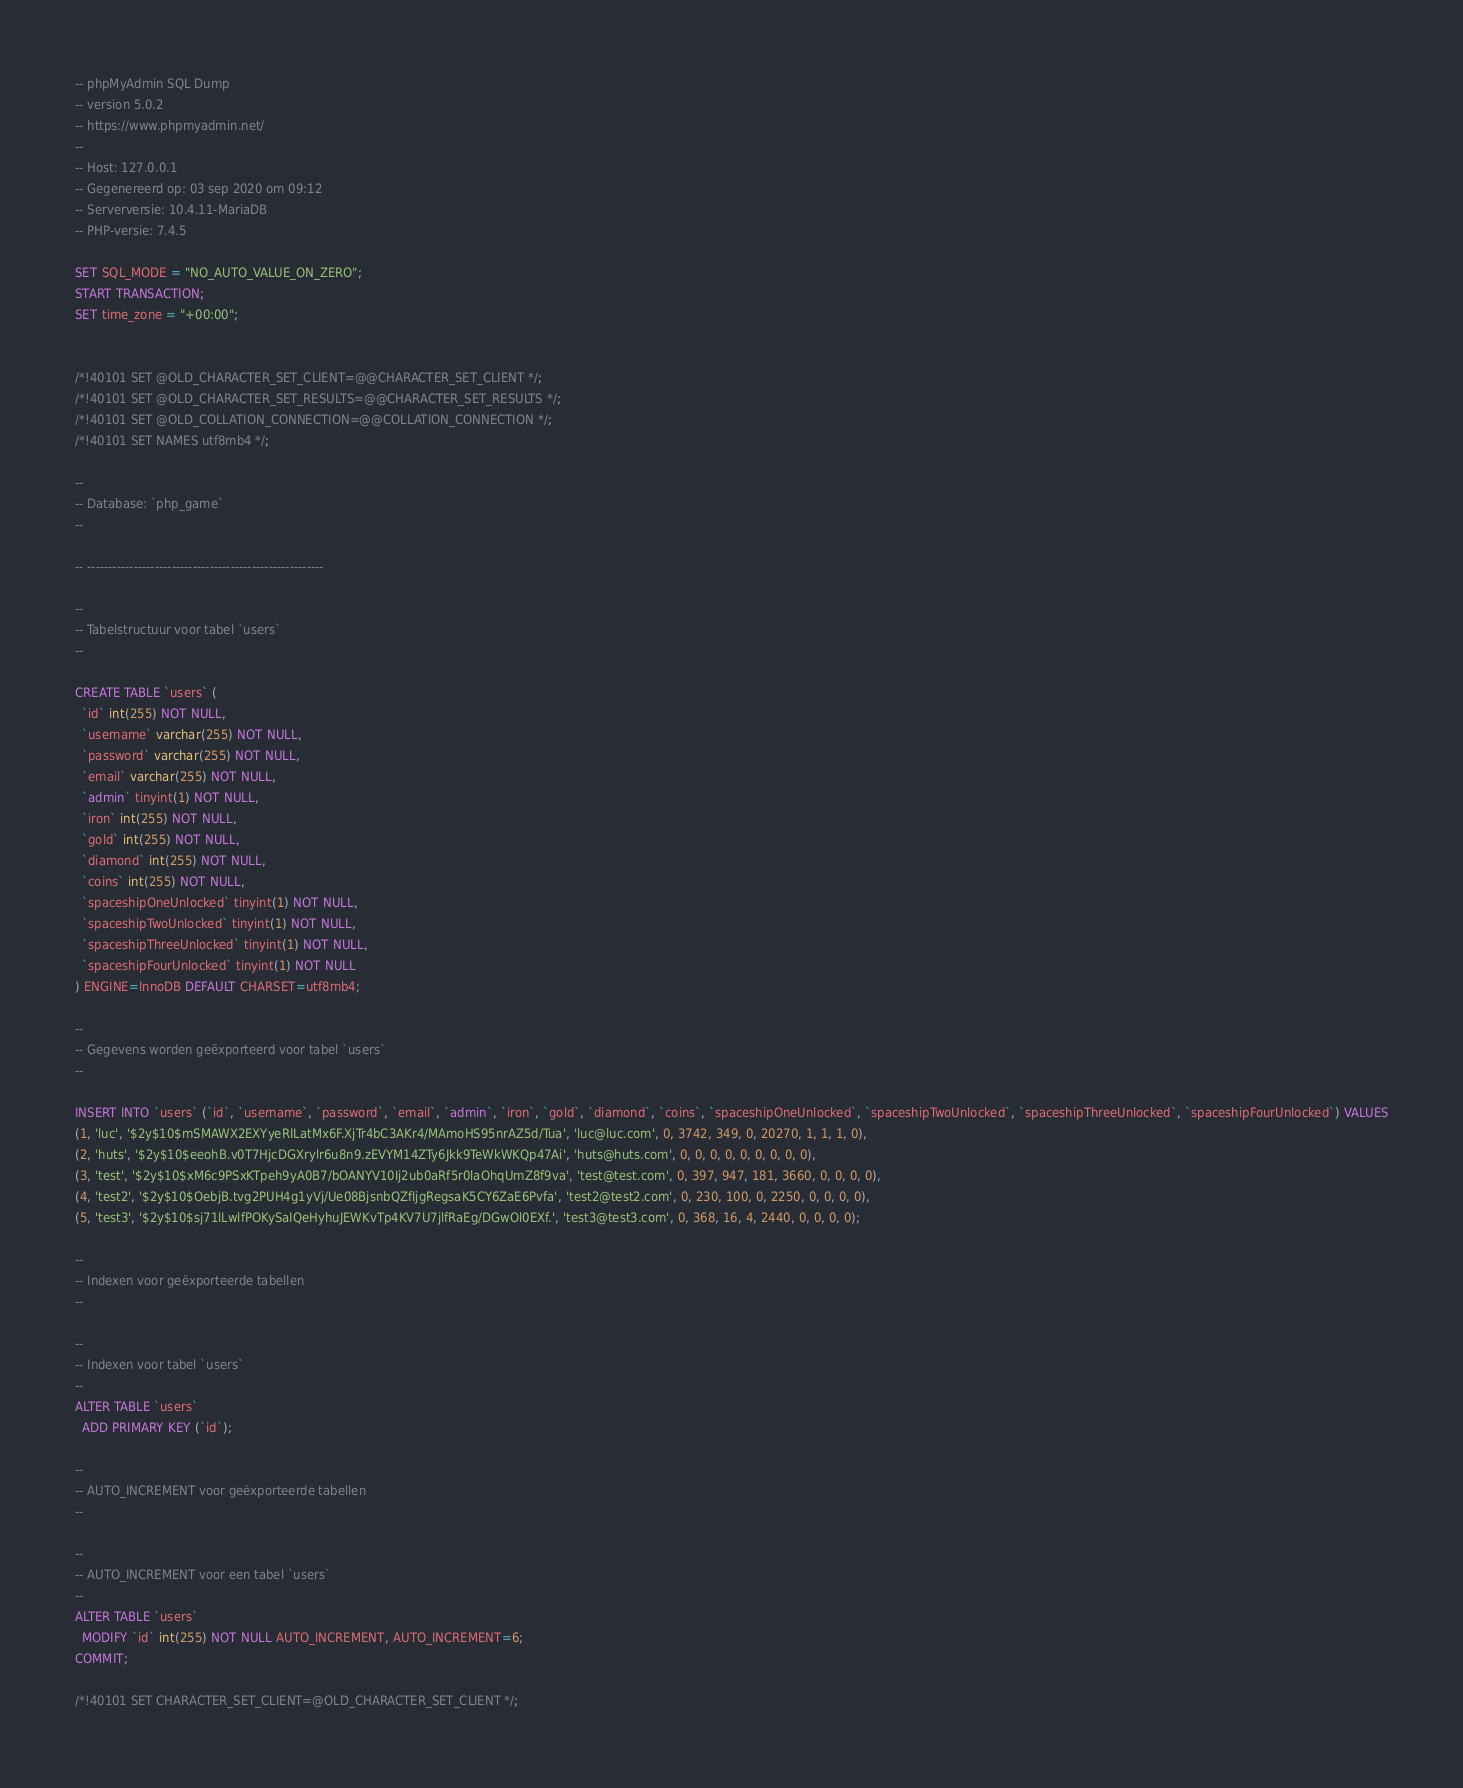Convert code to text. <code><loc_0><loc_0><loc_500><loc_500><_SQL_>-- phpMyAdmin SQL Dump
-- version 5.0.2
-- https://www.phpmyadmin.net/
--
-- Host: 127.0.0.1
-- Gegenereerd op: 03 sep 2020 om 09:12
-- Serverversie: 10.4.11-MariaDB
-- PHP-versie: 7.4.5

SET SQL_MODE = "NO_AUTO_VALUE_ON_ZERO";
START TRANSACTION;
SET time_zone = "+00:00";


/*!40101 SET @OLD_CHARACTER_SET_CLIENT=@@CHARACTER_SET_CLIENT */;
/*!40101 SET @OLD_CHARACTER_SET_RESULTS=@@CHARACTER_SET_RESULTS */;
/*!40101 SET @OLD_COLLATION_CONNECTION=@@COLLATION_CONNECTION */;
/*!40101 SET NAMES utf8mb4 */;

--
-- Database: `php_game`
--

-- --------------------------------------------------------

--
-- Tabelstructuur voor tabel `users`
--

CREATE TABLE `users` (
  `id` int(255) NOT NULL,
  `username` varchar(255) NOT NULL,
  `password` varchar(255) NOT NULL,
  `email` varchar(255) NOT NULL,
  `admin` tinyint(1) NOT NULL,
  `iron` int(255) NOT NULL,
  `gold` int(255) NOT NULL,
  `diamond` int(255) NOT NULL,
  `coins` int(255) NOT NULL,
  `spaceshipOneUnlocked` tinyint(1) NOT NULL,
  `spaceshipTwoUnlocked` tinyint(1) NOT NULL,
  `spaceshipThreeUnlocked` tinyint(1) NOT NULL,
  `spaceshipFourUnlocked` tinyint(1) NOT NULL
) ENGINE=InnoDB DEFAULT CHARSET=utf8mb4;

--
-- Gegevens worden geëxporteerd voor tabel `users`
--

INSERT INTO `users` (`id`, `username`, `password`, `email`, `admin`, `iron`, `gold`, `diamond`, `coins`, `spaceshipOneUnlocked`, `spaceshipTwoUnlocked`, `spaceshipThreeUnlocked`, `spaceshipFourUnlocked`) VALUES
(1, 'luc', '$2y$10$mSMAWX2EXYyeRILatMx6F.XjTr4bC3AKr4/MAmoHS95nrAZ5d/Tua', 'luc@luc.com', 0, 3742, 349, 0, 20270, 1, 1, 1, 0),
(2, 'huts', '$2y$10$eeohB.v0T7HjcDGXrylr6u8n9.zEVYM14ZTy6Jkk9TeWkWKQp47Ai', 'huts@huts.com', 0, 0, 0, 0, 0, 0, 0, 0, 0),
(3, 'test', '$2y$10$xM6c9PSxKTpeh9yA0B7/bOANYV10Ij2ub0aRf5r0laOhqUmZ8f9va', 'test@test.com', 0, 397, 947, 181, 3660, 0, 0, 0, 0),
(4, 'test2', '$2y$10$OebjB.tvg2PUH4g1yVj/Ue08BjsnbQZfIjgRegsaK5CY6ZaE6Pvfa', 'test2@test2.com', 0, 230, 100, 0, 2250, 0, 0, 0, 0),
(5, 'test3', '$2y$10$sj71lLwlfPOKySaIQeHyhuJEWKvTp4KV7U7jlfRaEg/DGwOl0EXf.', 'test3@test3.com', 0, 368, 16, 4, 2440, 0, 0, 0, 0);

--
-- Indexen voor geëxporteerde tabellen
--

--
-- Indexen voor tabel `users`
--
ALTER TABLE `users`
  ADD PRIMARY KEY (`id`);

--
-- AUTO_INCREMENT voor geëxporteerde tabellen
--

--
-- AUTO_INCREMENT voor een tabel `users`
--
ALTER TABLE `users`
  MODIFY `id` int(255) NOT NULL AUTO_INCREMENT, AUTO_INCREMENT=6;
COMMIT;

/*!40101 SET CHARACTER_SET_CLIENT=@OLD_CHARACTER_SET_CLIENT */;</code> 